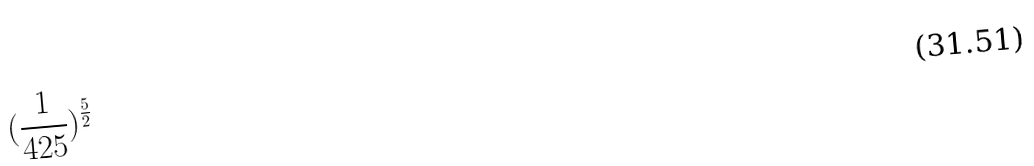<formula> <loc_0><loc_0><loc_500><loc_500>( \frac { 1 } { 4 2 5 } ) ^ { \frac { 5 } { 2 } }</formula> 